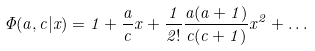Convert formula to latex. <formula><loc_0><loc_0><loc_500><loc_500>\Phi ( a , c | x ) = 1 + \frac { a } { c } x + \frac { 1 } { 2 ! } \frac { a ( a + 1 ) } { c ( c + 1 ) } x ^ { 2 } + \dots</formula> 